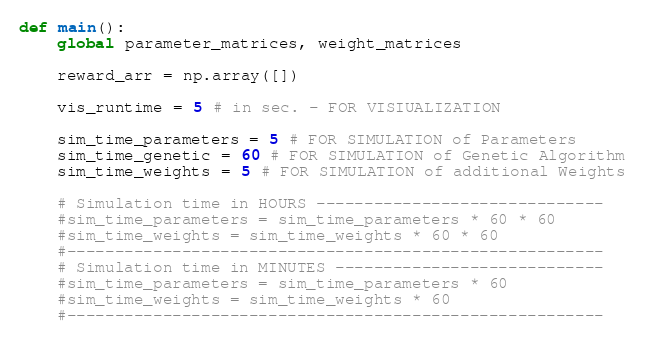Convert code to text. <code><loc_0><loc_0><loc_500><loc_500><_Python_>


def main():
    global parameter_matrices, weight_matrices

    reward_arr = np.array([])

    vis_runtime = 5 # in sec. - FOR VISIUALIZATION

    sim_time_parameters = 5 # FOR SIMULATION of Parameters
    sim_time_genetic = 60 # FOR SIMULATION of Genetic Algorithm
    sim_time_weights = 5 # FOR SIMULATION of additional Weights

    # Simulation time in HOURS ------------------------------
    #sim_time_parameters = sim_time_parameters * 60 * 60
    #sim_time_weights = sim_time_weights * 60 * 60
    #--------------------------------------------------------
    # Simulation time in MINUTES ----------------------------
    #sim_time_parameters = sim_time_parameters * 60
    #sim_time_weights = sim_time_weights * 60
    #--------------------------------------------------------
</code> 